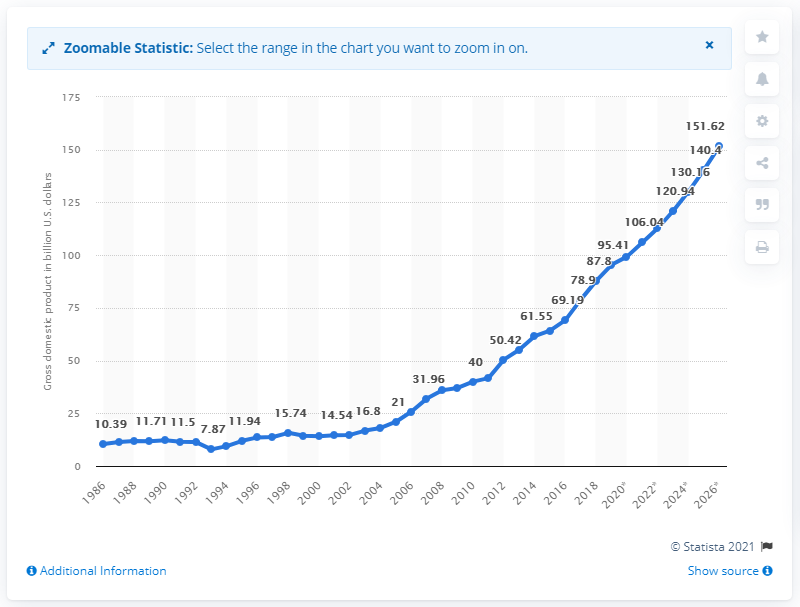Give some essential details in this illustration. In 2019, Kenya's gross domestic product (GDP) was 95.41. 